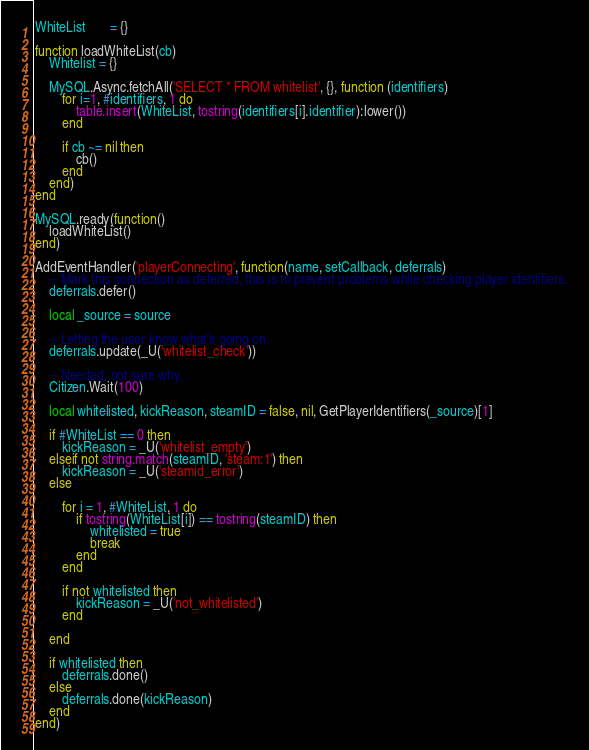<code> <loc_0><loc_0><loc_500><loc_500><_Lua_>WhiteList       = {}

function loadWhiteList(cb)
	Whitelist = {}

	MySQL.Async.fetchAll('SELECT * FROM whitelist', {}, function (identifiers)
		for i=1, #identifiers, 1 do
			table.insert(WhiteList, tostring(identifiers[i].identifier):lower())
		end

		if cb ~= nil then
			cb()
		end
	end)
end

MySQL.ready(function()
	loadWhiteList()
end)

AddEventHandler('playerConnecting', function(name, setCallback, deferrals)
	-- Mark this connection as deferred, this is to prevent problems while checking player identifiers.
	deferrals.defer()

	local _source = source
	
	-- Letting the user know what's going on.
	deferrals.update(_U('whitelist_check'))
	
	-- Needed, not sure why.
	Citizen.Wait(100)

	local whitelisted, kickReason, steamID = false, nil, GetPlayerIdentifiers(_source)[1]

	if #WhiteList == 0 then
		kickReason = _U('whitelist_empty')
	elseif not string.match(steamID, 'steam:1') then
		kickReason = _U('steamid_error')
	else

		for i = 1, #WhiteList, 1 do
			if tostring(WhiteList[i]) == tostring(steamID) then
				whitelisted = true
				break
			end
		end

		if not whitelisted then
			kickReason = _U('not_whitelisted')
		end

	end

	if whitelisted then
		deferrals.done()
	else
		deferrals.done(kickReason)
	end
end)
</code> 